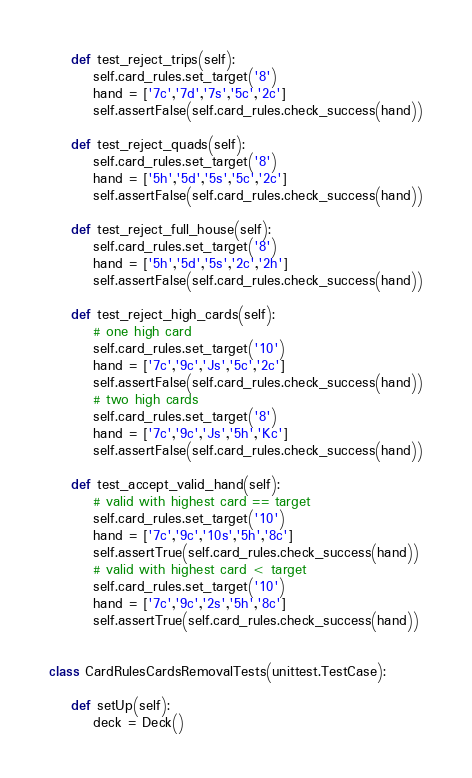Convert code to text. <code><loc_0><loc_0><loc_500><loc_500><_Python_>
    def test_reject_trips(self):
        self.card_rules.set_target('8')
        hand = ['7c','7d','7s','5c','2c']
        self.assertFalse(self.card_rules.check_success(hand))

    def test_reject_quads(self):
        self.card_rules.set_target('8')
        hand = ['5h','5d','5s','5c','2c']
        self.assertFalse(self.card_rules.check_success(hand))

    def test_reject_full_house(self):
        self.card_rules.set_target('8')
        hand = ['5h','5d','5s','2c','2h']
        self.assertFalse(self.card_rules.check_success(hand))

    def test_reject_high_cards(self):
        # one high card
        self.card_rules.set_target('10')
        hand = ['7c','9c','Js','5c','2c']
        self.assertFalse(self.card_rules.check_success(hand))
        # two high cards
        self.card_rules.set_target('8')
        hand = ['7c','9c','Js','5h','Kc']
        self.assertFalse(self.card_rules.check_success(hand))

    def test_accept_valid_hand(self):
        # valid with highest card == target
        self.card_rules.set_target('10')
        hand = ['7c','9c','10s','5h','8c']
        self.assertTrue(self.card_rules.check_success(hand))
        # valid with highest card < target
        self.card_rules.set_target('10')
        hand = ['7c','9c','2s','5h','8c']
        self.assertTrue(self.card_rules.check_success(hand))


class CardRulesCardsRemovalTests(unittest.TestCase):

    def setUp(self):
        deck = Deck()</code> 